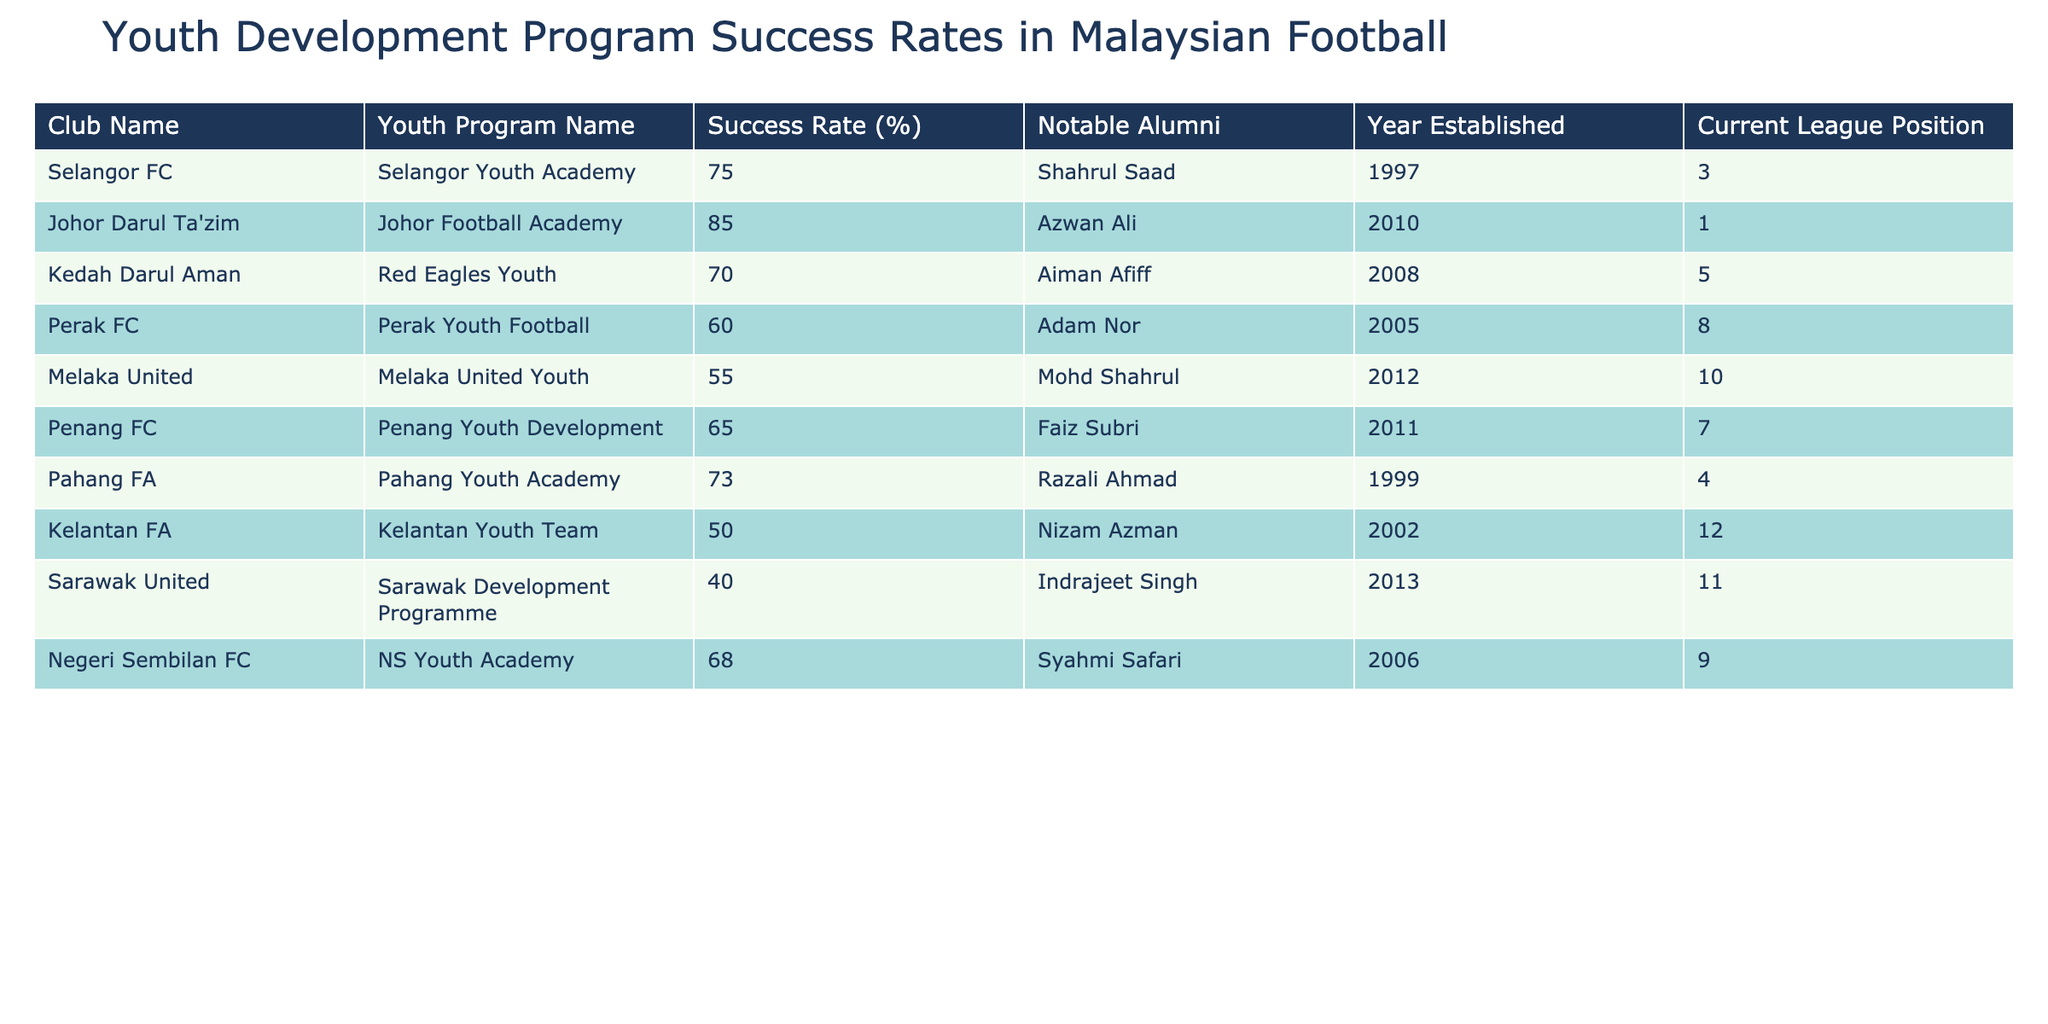What is the success rate of Johor Football Academy? According to the table, the success rate of the Johor Football Academy is listed directly under its corresponding column, which states it as 85 percent.
Answer: 85% Which club has the lowest success rate? By examining the success rates listed for each club in the table, Sarawak United has the lowest at 40 percent, making it the club with the lowest success rate.
Answer: Sarawak United What is the average success rate of the youth programs listed? To find the average success rate, sum all the success rates of the clubs (75 + 85 + 70 + 60 + 55 + 65 + 73 + 50 + 40 + 68) =  693. There are ten clubs, so the average is 693/10 = 69.3 percent.
Answer: 69.3% Is it true that all clubs established after 2005 have a success rate of over 60%? Checking each club established after 2005, we find Melaka United (55%), which has a success rate below 60%. Therefore, the statement is false.
Answer: No What is the difference in success rates between the highest and lowest-performing youth programs? The highest success rate is from the Johor Football Academy at 85 percent, and the lowest is from Sarawak United at 40 percent. Thus, the difference is 85 - 40 = 45 percent.
Answer: 45% How many notable alumni does the Pahang Youth Academy have mentioned in the table? The table lists one notable alumni for the Pahang Youth Academy, which is Razali Ahmad. Therefore, the number of notable alumni is one.
Answer: 1 Which club has both a higher success rate than Perak FC and a better league position? Perak FC has a success rate of 60 percent and is currently in the 8th position. Looking at the table, Selangor FC (75%, 3rd position) and Pahang FA (73%, 4th position) both have higher success rates and better league positions.
Answer: Selangor FC, Pahang FA Do any clubs have a success rate of exactly 70%? The table lists Kedah Darul Aman with a success rate of 70 percent, confirming that there is at least one club with this exact rate.
Answer: Yes 